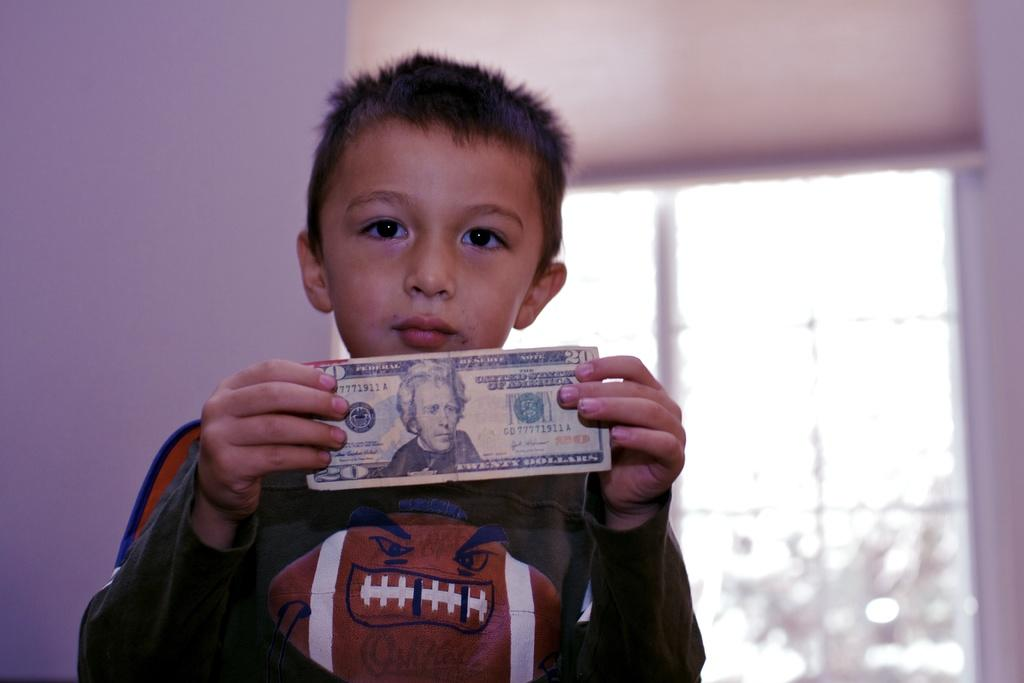<image>
Describe the image concisely. boy wearing angry football shirt is holding a twenty dollar bill 